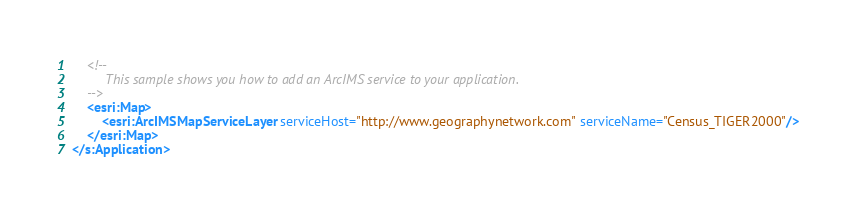<code> <loc_0><loc_0><loc_500><loc_500><_XML_>    <!--
         This sample shows you how to add an ArcIMS service to your application.
    -->
    <esri:Map>
        <esri:ArcIMSMapServiceLayer serviceHost="http://www.geographynetwork.com" serviceName="Census_TIGER2000"/>
    </esri:Map>
</s:Application>
</code> 